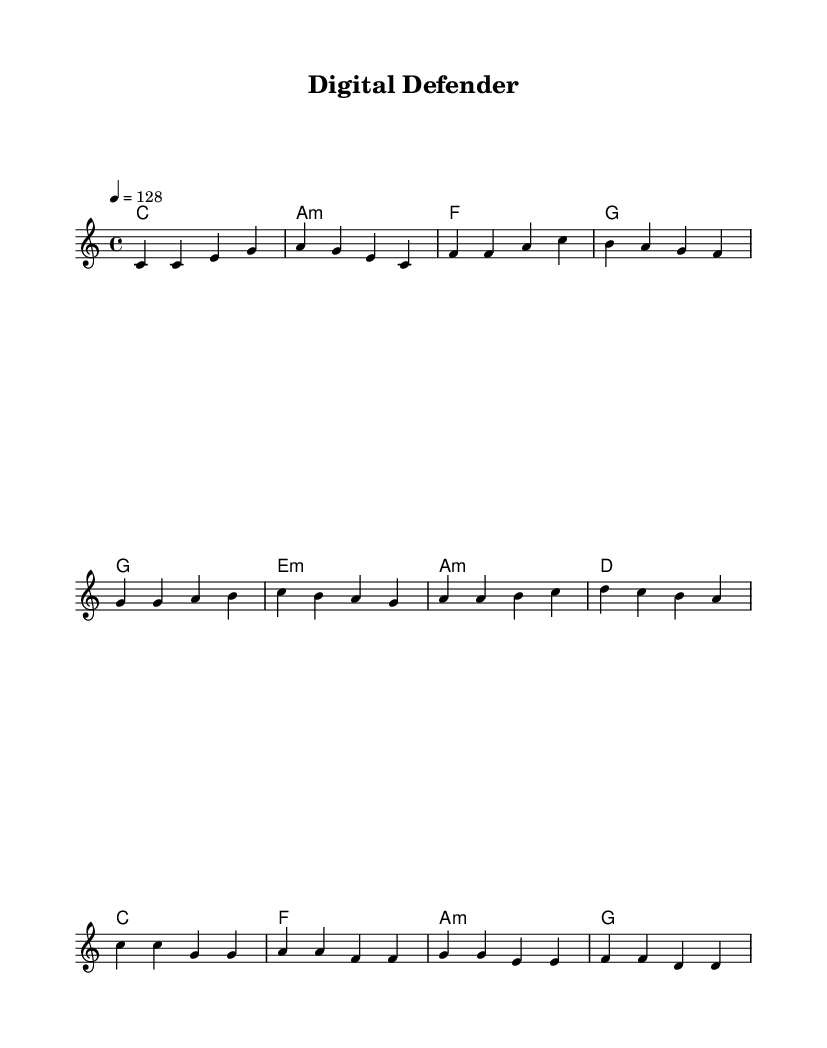What is the key signature of this music? The key signature is indicated at the beginning of the score, showing no sharps or flats, which means it is C major.
Answer: C major What is the time signature of this music? The time signature is also provided at the beginning of the score and is indicated as 4/4, meaning there are four beats in each measure.
Answer: 4/4 What is the tempo marking for this piece? The tempo marking appears near the beginning of the score, stated as 4 = 128, indicating a moderate tempo of 128 beats per minute.
Answer: 128 How many measures are in the chorus? By counting the measures in the chorus section of the score, there are a total of four measures indicated.
Answer: 4 What is the first word of the song? The first word is found in the lyrics written under the melody, which starts with "Pro" from the verse.
Answer: Pro Which chords are used in the pre-chorus? Analyzing the chord names listed under the pre-chorus section reveals the chords as G, E minor, A minor, and D.
Answer: G, E minor, A minor, D How does the chorus express the theme of digital security? The lyrics of the chorus clearly emphasize safety and protection in the digital realm, stating lines about being a "digital defender" and guarding privacy.
Answer: Digital defender 